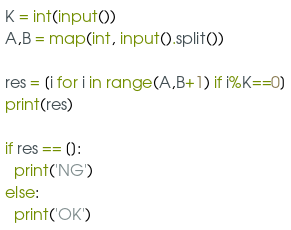Convert code to text. <code><loc_0><loc_0><loc_500><loc_500><_Python_>K = int(input())
A,B = map(int, input().split())

res = [i for i in range(A,B+1) if i%K==0]
print(res)

if res == []:
  print('NG')
else:
  print('OK')</code> 